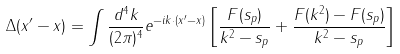Convert formula to latex. <formula><loc_0><loc_0><loc_500><loc_500>\Delta ( x ^ { \prime } - x ) = \int \frac { d ^ { 4 } k } { ( 2 \pi ) ^ { 4 } } e ^ { - i k \cdot ( x ^ { \prime } - x ) } \left [ \frac { F ( s _ { p } ) } { k ^ { 2 } - s _ { p } } + \frac { F ( k ^ { 2 } ) - F ( s _ { p } ) } { k ^ { 2 } - s _ { p } } \right ]</formula> 